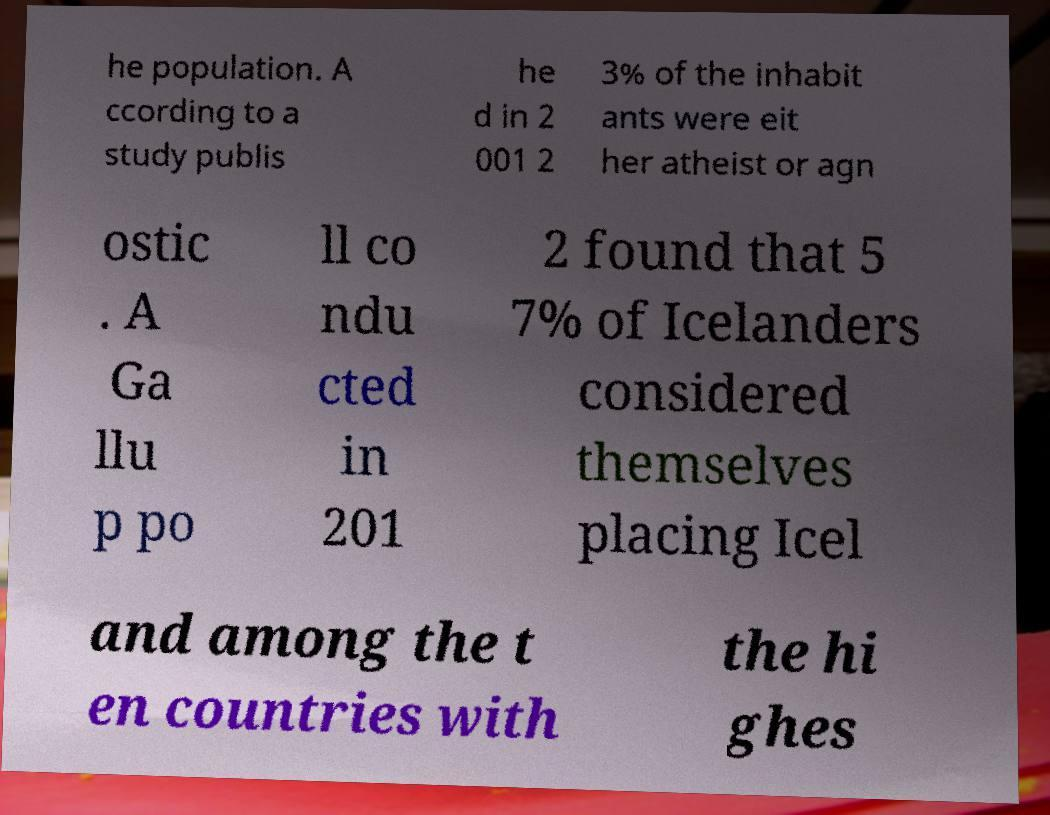For documentation purposes, I need the text within this image transcribed. Could you provide that? he population. A ccording to a study publis he d in 2 001 2 3% of the inhabit ants were eit her atheist or agn ostic . A Ga llu p po ll co ndu cted in 201 2 found that 5 7% of Icelanders considered themselves placing Icel and among the t en countries with the hi ghes 